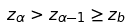Convert formula to latex. <formula><loc_0><loc_0><loc_500><loc_500>z _ { \alpha } > z _ { \alpha - 1 } \geq z _ { b }</formula> 